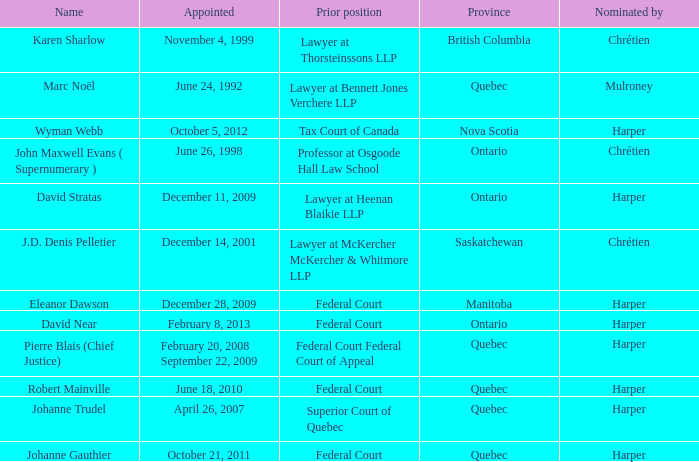Can you parse all the data within this table? {'header': ['Name', 'Appointed', 'Prior position', 'Province', 'Nominated by'], 'rows': [['Karen Sharlow', 'November 4, 1999', 'Lawyer at Thorsteinssons LLP', 'British Columbia', 'Chrétien'], ['Marc Noël', 'June 24, 1992', 'Lawyer at Bennett Jones Verchere LLP', 'Quebec', 'Mulroney'], ['Wyman Webb', 'October 5, 2012', 'Tax Court of Canada', 'Nova Scotia', 'Harper'], ['John Maxwell Evans ( Supernumerary )', 'June 26, 1998', 'Professor at Osgoode Hall Law School', 'Ontario', 'Chrétien'], ['David Stratas', 'December 11, 2009', 'Lawyer at Heenan Blaikie LLP', 'Ontario', 'Harper'], ['J.D. Denis Pelletier', 'December 14, 2001', 'Lawyer at McKercher McKercher & Whitmore LLP', 'Saskatchewan', 'Chrétien'], ['Eleanor Dawson', 'December 28, 2009', 'Federal Court', 'Manitoba', 'Harper'], ['David Near', 'February 8, 2013', 'Federal Court', 'Ontario', 'Harper'], ['Pierre Blais (Chief Justice)', 'February 20, 2008 September 22, 2009', 'Federal Court Federal Court of Appeal', 'Quebec', 'Harper'], ['Robert Mainville', 'June 18, 2010', 'Federal Court', 'Quebec', 'Harper'], ['Johanne Trudel', 'April 26, 2007', 'Superior Court of Quebec', 'Quebec', 'Harper'], ['Johanne Gauthier', 'October 21, 2011', 'Federal Court', 'Quebec', 'Harper']]} Who was appointed on October 21, 2011 from Quebec? Johanne Gauthier. 